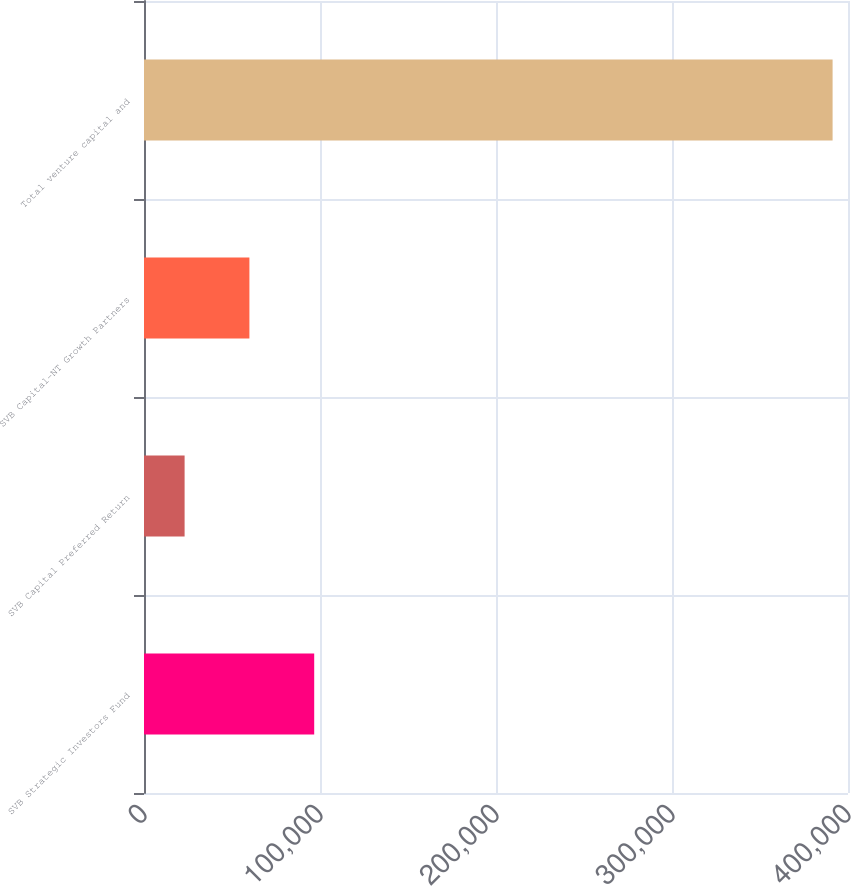<chart> <loc_0><loc_0><loc_500><loc_500><bar_chart><fcel>SVB Strategic Investors Fund<fcel>SVB Capital Preferred Return<fcel>SVB Capital-NT Growth Partners<fcel>Total venture capital and<nl><fcel>96706.2<fcel>23071<fcel>59888.6<fcel>391247<nl></chart> 